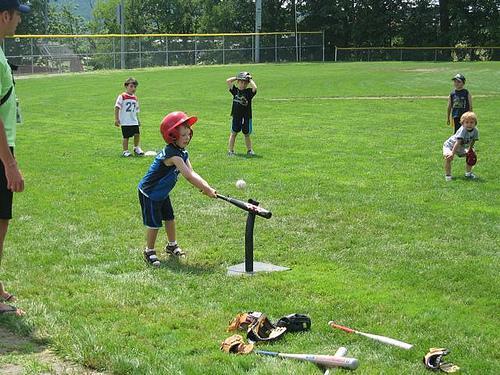How many bats are on the ground?
Give a very brief answer. 3. How many people are in the picture?
Give a very brief answer. 2. 